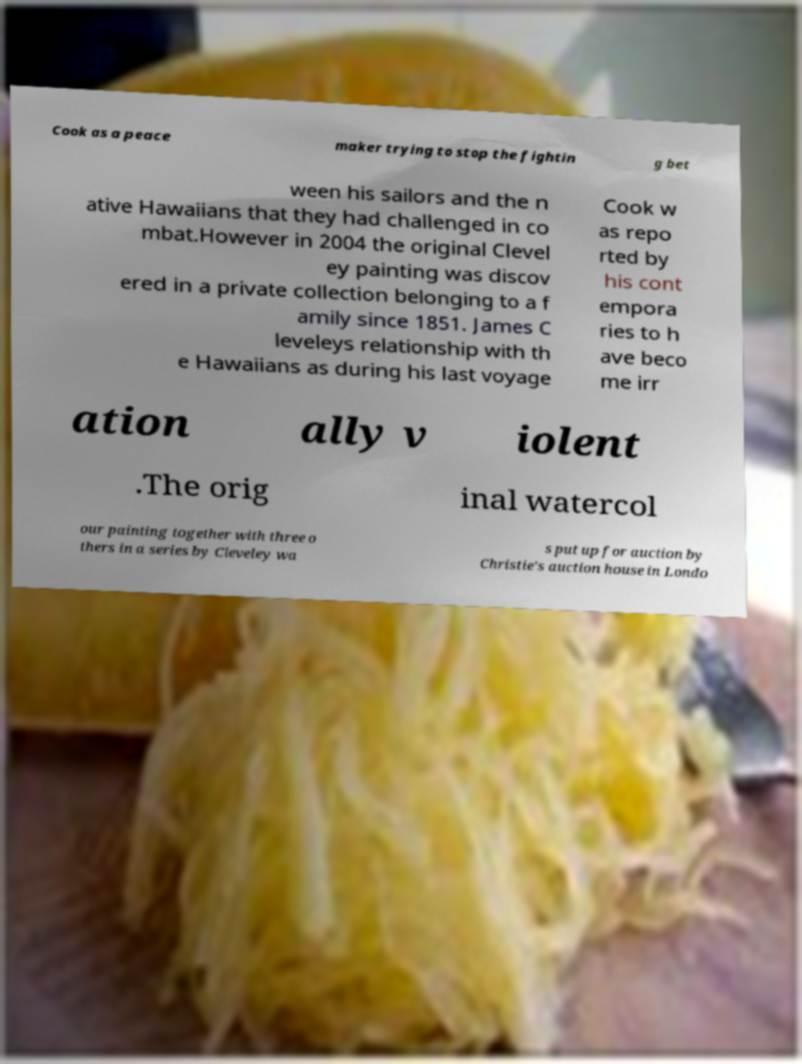Can you read and provide the text displayed in the image?This photo seems to have some interesting text. Can you extract and type it out for me? Cook as a peace maker trying to stop the fightin g bet ween his sailors and the n ative Hawaiians that they had challenged in co mbat.However in 2004 the original Clevel ey painting was discov ered in a private collection belonging to a f amily since 1851. James C leveleys relationship with th e Hawaiians as during his last voyage Cook w as repo rted by his cont empora ries to h ave beco me irr ation ally v iolent .The orig inal watercol our painting together with three o thers in a series by Cleveley wa s put up for auction by Christie's auction house in Londo 